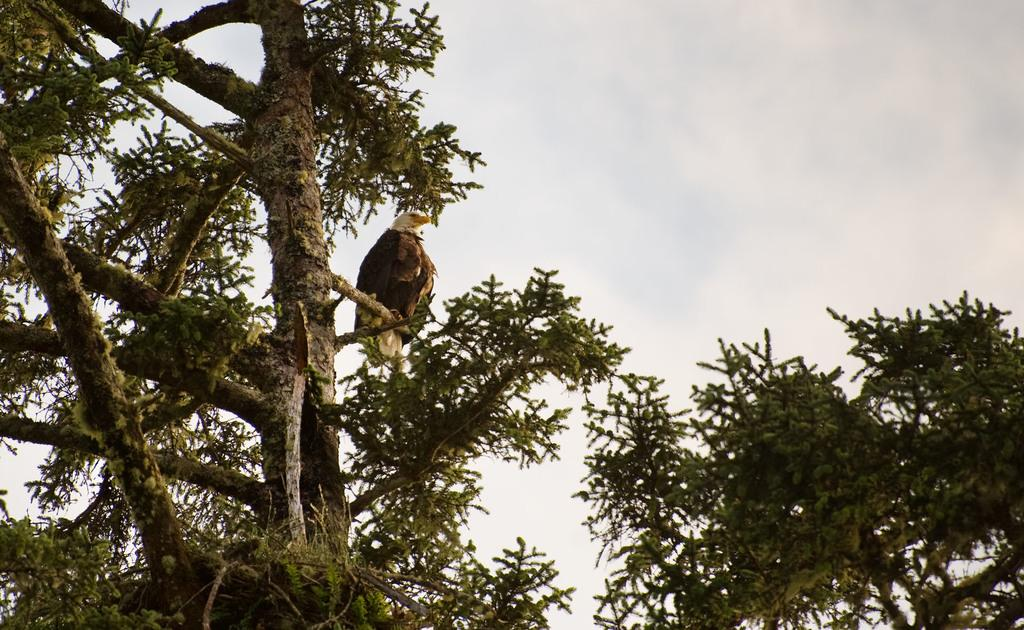What can be seen in the picture? There is a tree in the picture. Is there anything on the tree? Yes, there is an eagle on the tree. How would you describe the sky in the picture? The sky is cloudy. Where is the shelf located in the picture? There is no shelf present in the picture. What type of tank can be seen in the image? There is no tank present in the image. 